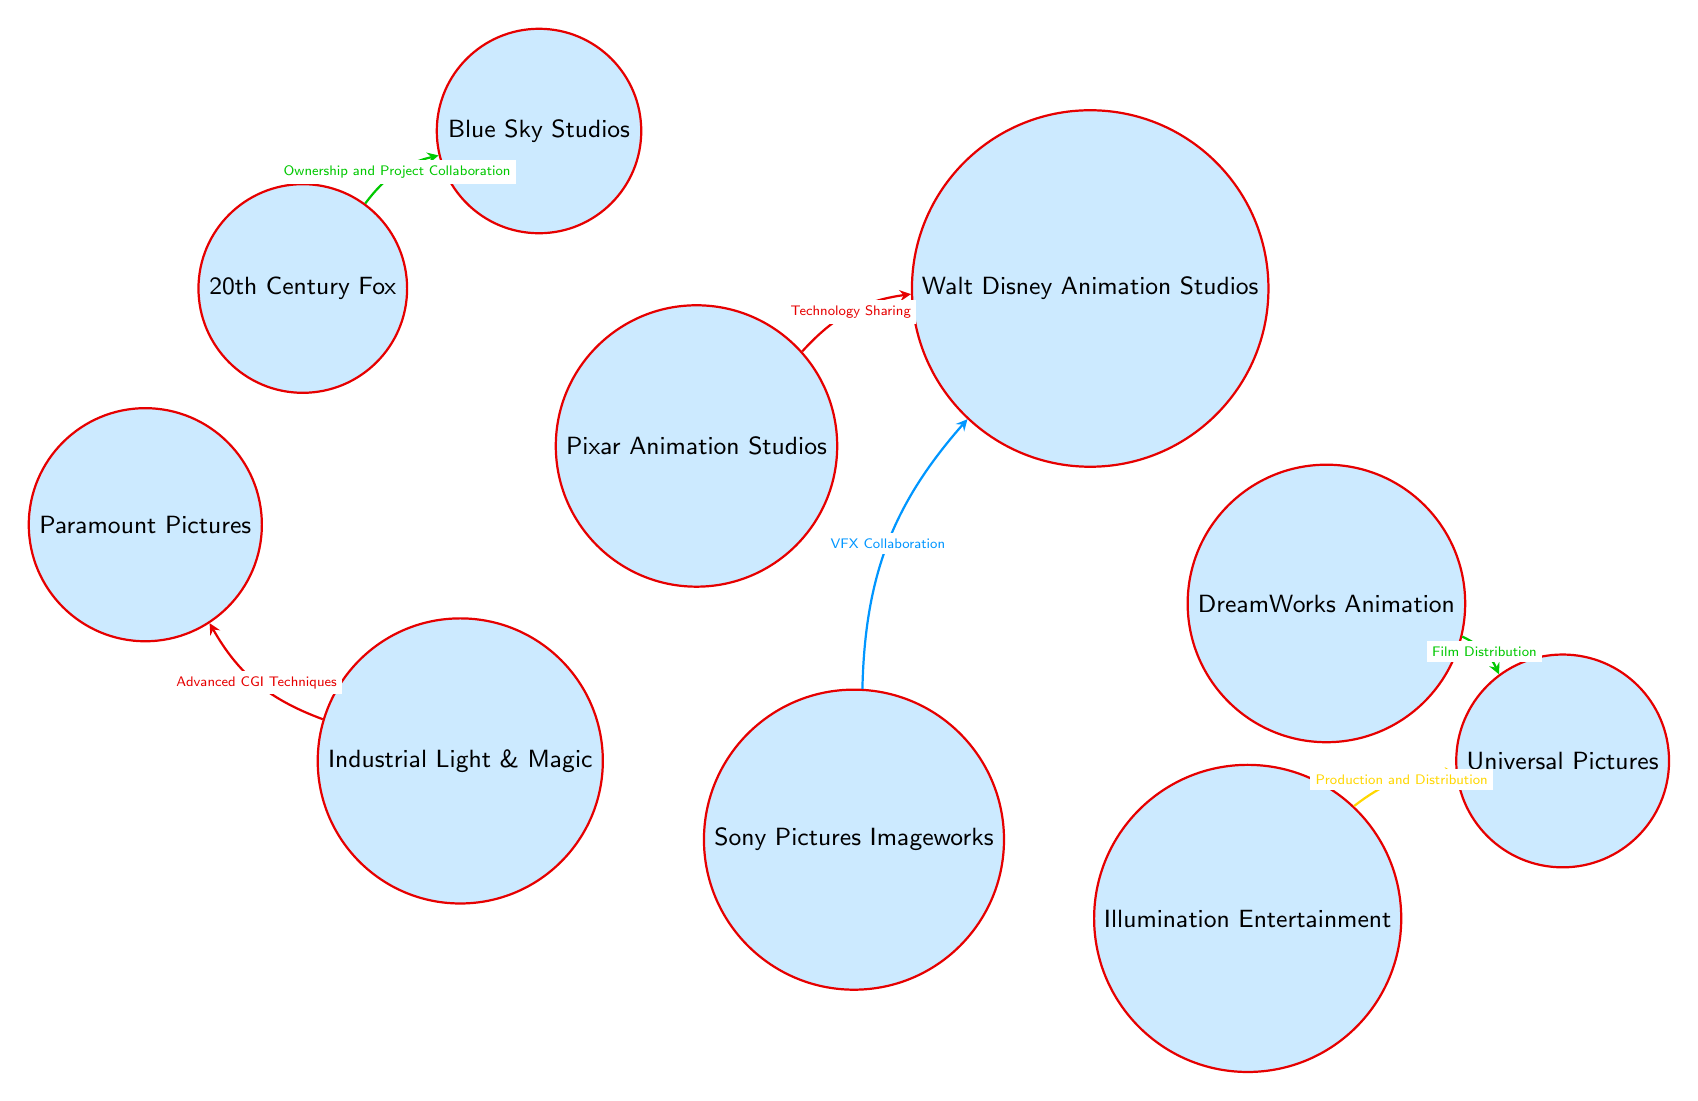What's the total number of studios represented in the diagram? The diagram lists ten studios: Pixar Animation Studios, Walt Disney Animation Studios, DreamWorks Animation, Industrial Light & Magic, Sony Pictures Imageworks, Illumination Entertainment, Universal Pictures, 20th Century Fox, Paramount Pictures, and Blue Sky Studios. Counting each gives us a total of ten.
Answer: 10 What type of collaboration exists between Pixar Animation Studios and Walt Disney Animation Studios? The link connecting Pixar Animation Studios and Walt Disney Animation Studios is labeled "Technology Sharing." This indicates the nature of their collaboration.
Answer: Technology Sharing Which studio collaborates with Universal Pictures for film distribution? The diagram shows a link from DreamWorks Animation to Universal Pictures labeled "Film Distribution." This indicates that DreamWorks Animation is the studio collaborating with Universal Pictures in this manner.
Answer: DreamWorks Animation How many links are connected to Walt Disney Animation Studios? The diagram shows two links connected to Walt Disney Animation Studios: one from Pixar Animation Studios (Technology Sharing) and another from Sony Pictures Imageworks (VFX Collaboration). Therefore, there are a total of two connections.
Answer: 2 What kind of collaboration is depicted between Sony Pictures Imageworks and Walt Disney Animation Studios? The link between Sony Pictures Imageworks and Walt Disney Animation Studios indicates "VFX Collaboration," showing the specific type of collaboration between these two studios.
Answer: VFX Collaboration Which studio is connected to 20th Century Fox in terms of project collaboration? The diagram shows a link from 20th Century Fox to Blue Sky Studios labeled "Ownership and Project Collaboration." This indicates that Blue Sky Studios is connected to 20th Century Fox for project collaboration.
Answer: Blue Sky Studios What is the relationship between Industrial Light & Magic and Paramount Pictures? The diagram displays a connection labeled "Advanced CGI Techniques" from Industrial Light & Magic to Paramount Pictures, indicating the nature of their relationship in terms of CGI.
Answer: Advanced CGI Techniques Which studio is involved in both production and distribution with Universal Pictures? The diagram shows a link from Illumination Entertainment to Universal Pictures labeled "Production and Distribution," indicating that Illumination Entertainment is involved in both aspects with Universal.
Answer: Illumination Entertainment How do links between studios visually represent collaboration in this diagram? In this chord diagram, the lines connecting nodes (studios) illustrate the type of collaboration through labeled connections, showing various types of partnerships and relationships among the studios. Each label defines the nature of collaboration between the linked studios.
Answer: Collaboration types 